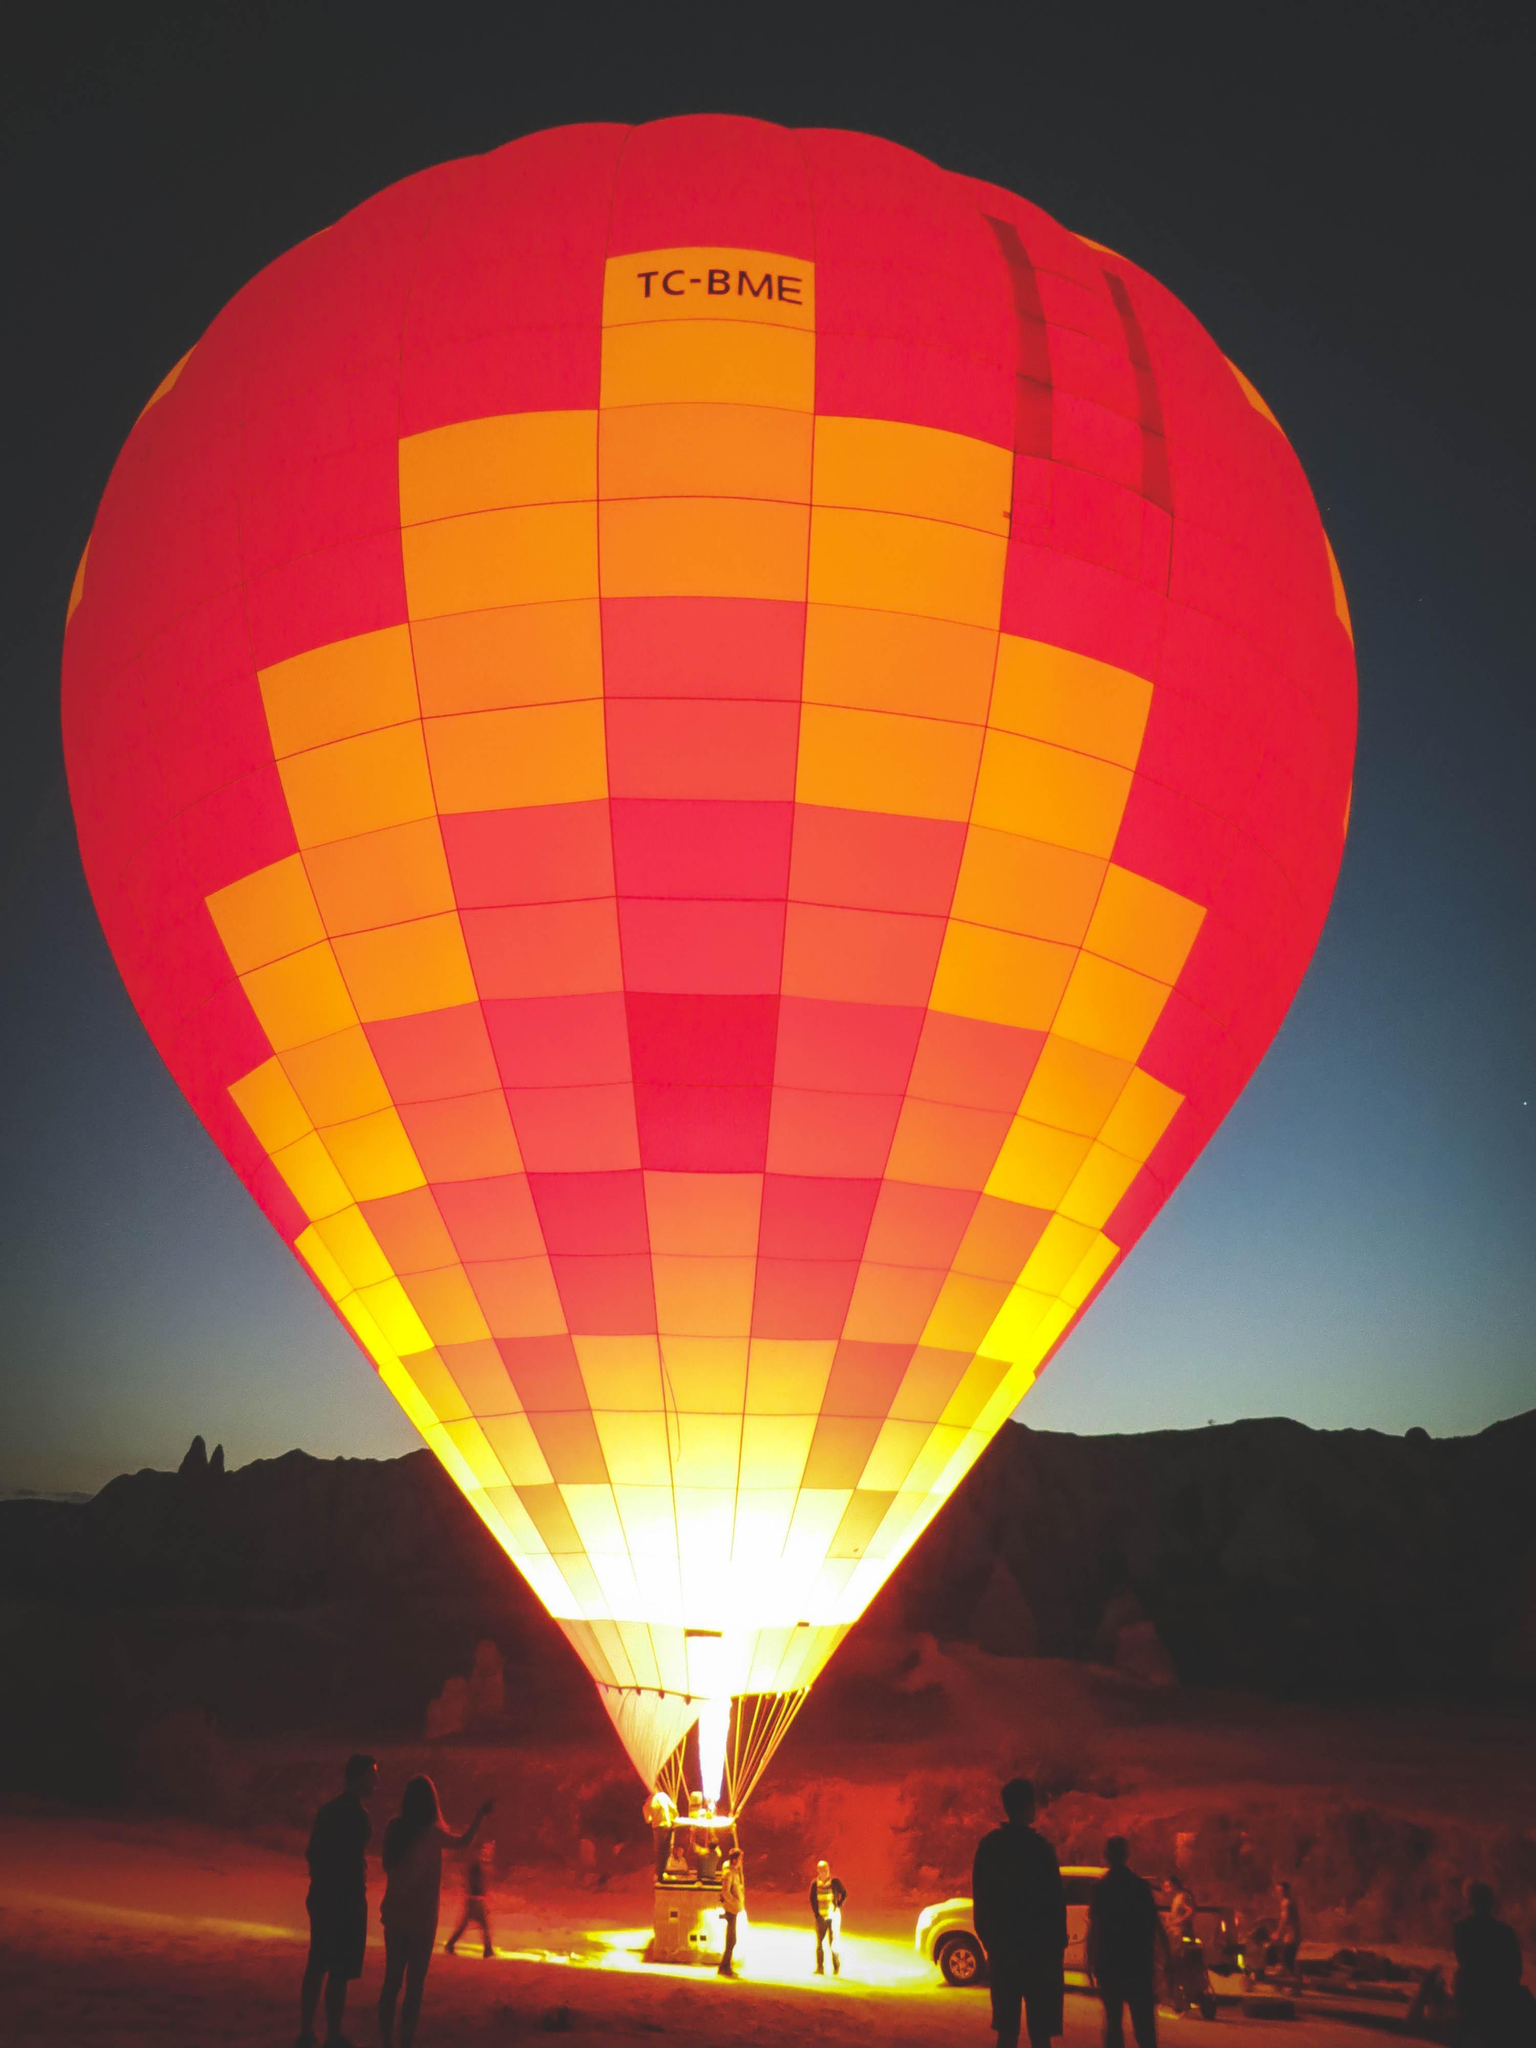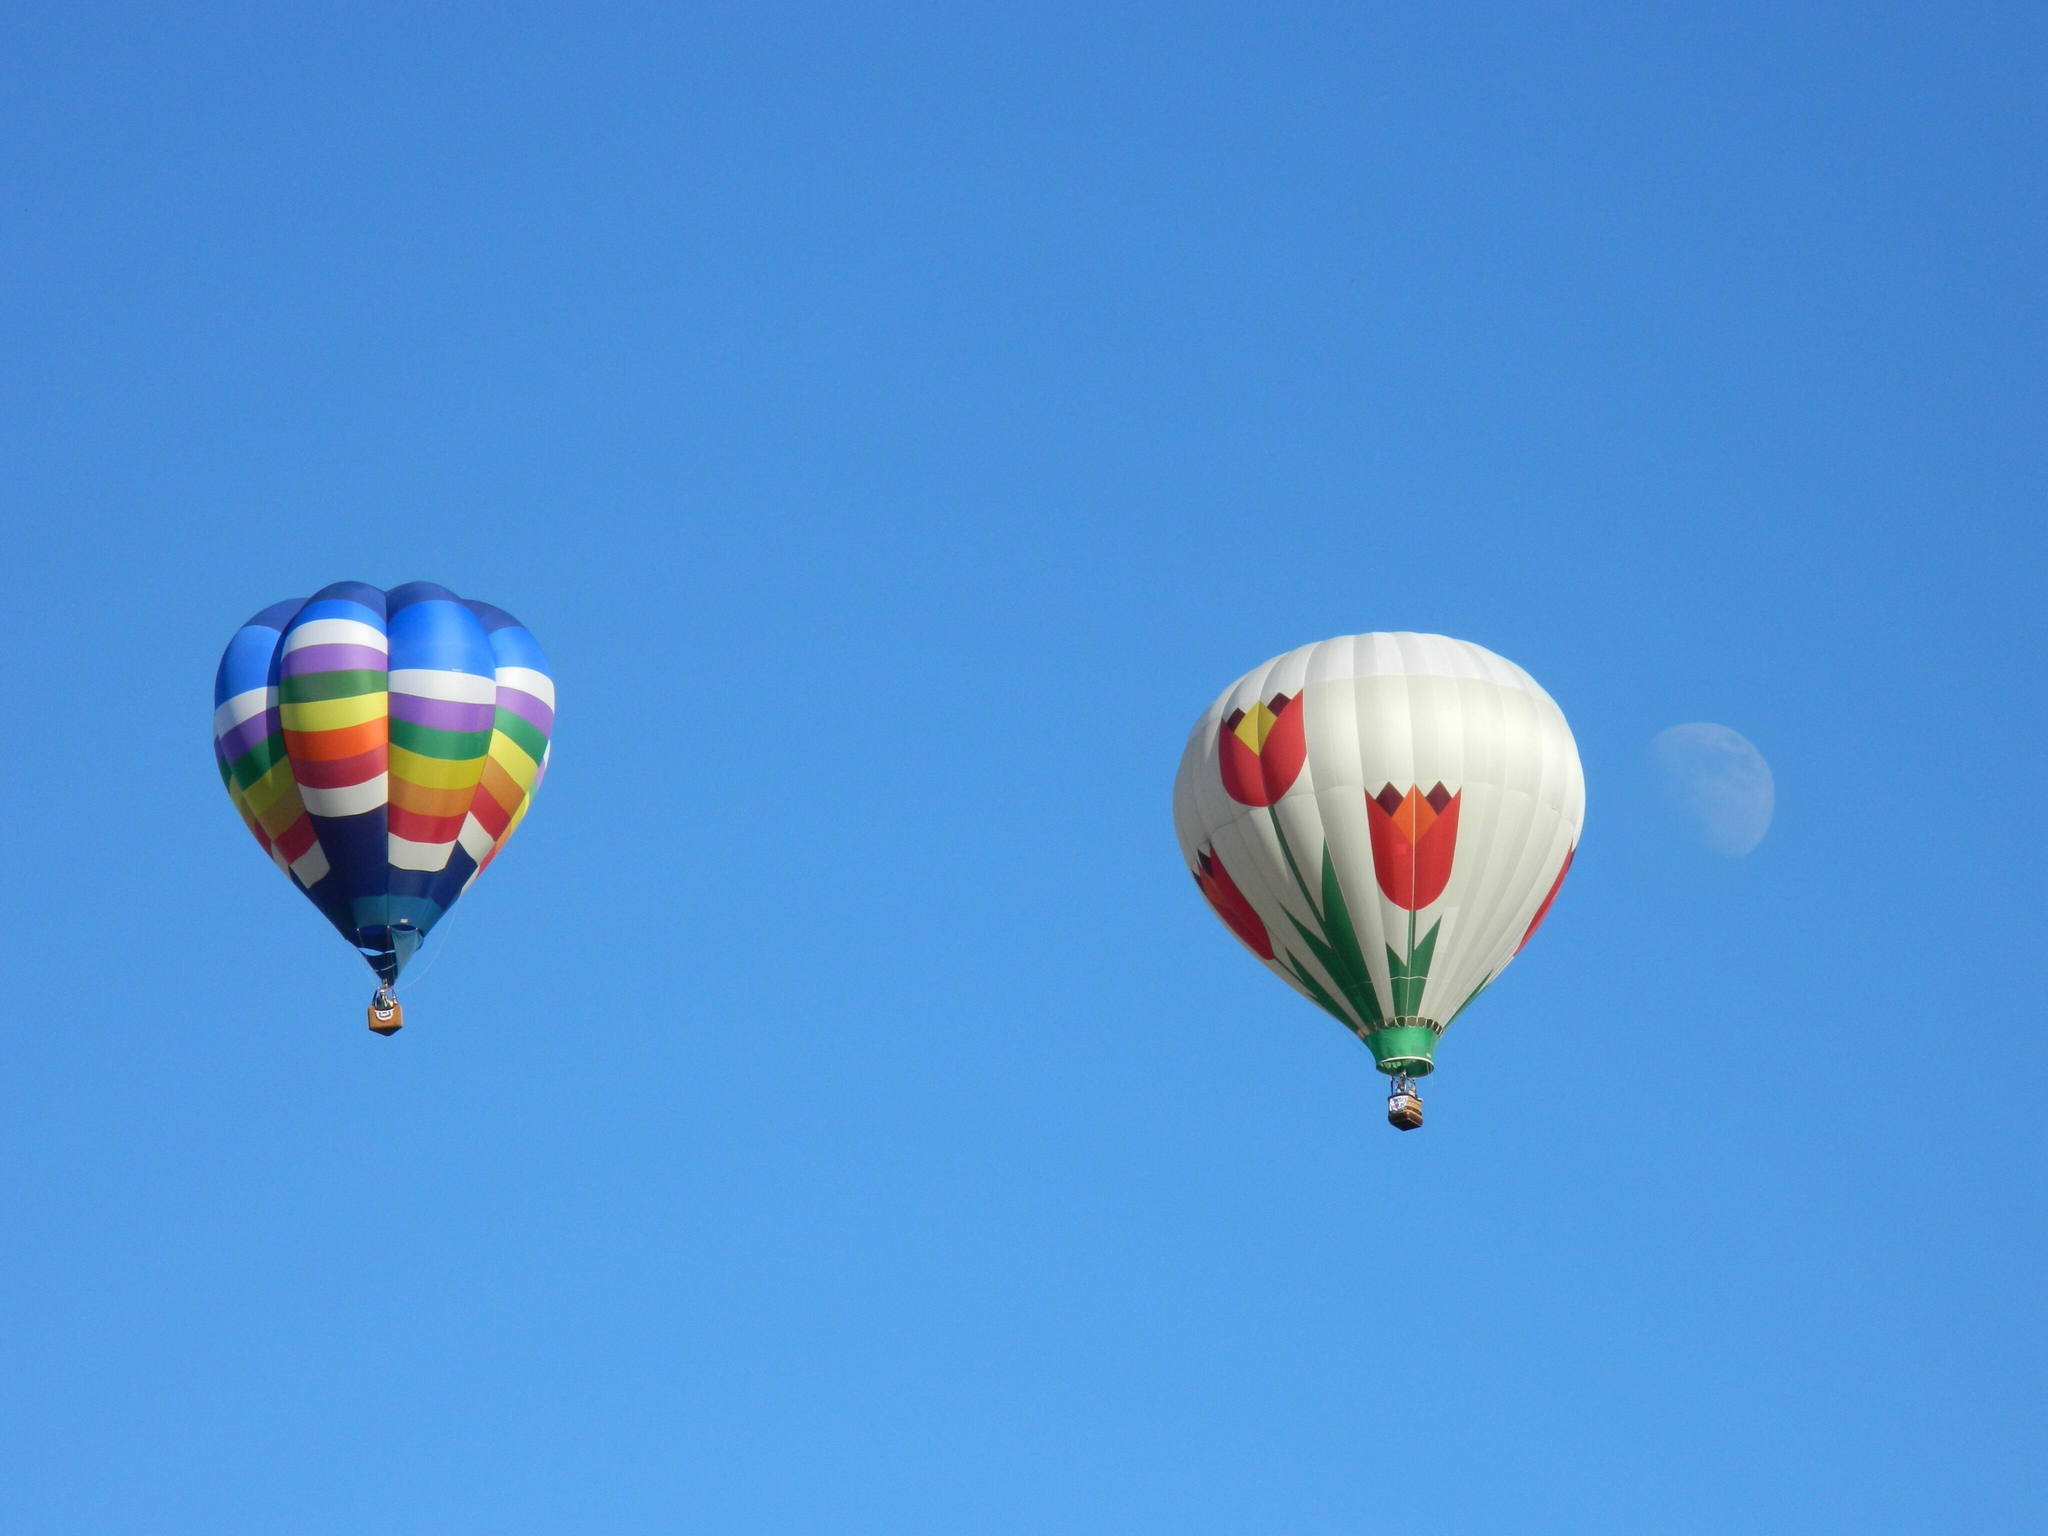The first image is the image on the left, the second image is the image on the right. Evaluate the accuracy of this statement regarding the images: "No images show balloons against blue sky.". Is it true? Answer yes or no. No. 